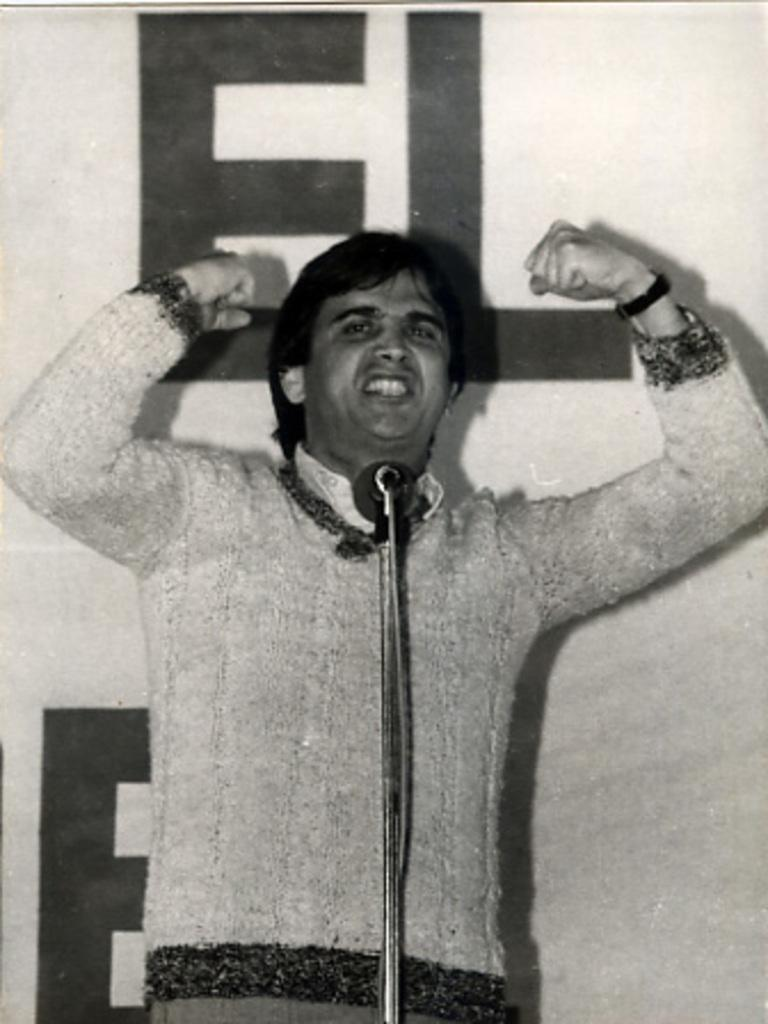What is the main subject of the image? There is a person standing in the image. What object is located in the foreground of the image? There is a microphone in the foreground of the image. What can be seen in the background of the image? There is a hoarding in the background of the image. What is written or displayed on the hoarding? There is text on the hoarding. How many feet are visible on the person in the image? The image does not show the person's feet, so it cannot be determined how many are visible. What type of spoon is being used by the person in the image? There is no spoon present in the image; the person is holding a microphone. 